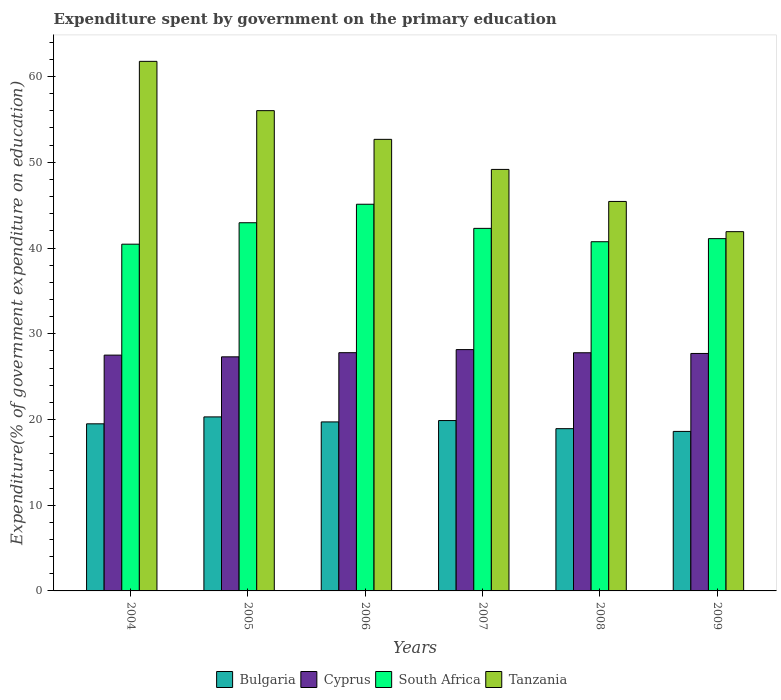How many bars are there on the 5th tick from the right?
Your answer should be very brief. 4. In how many cases, is the number of bars for a given year not equal to the number of legend labels?
Provide a short and direct response. 0. What is the expenditure spent by government on the primary education in Tanzania in 2006?
Make the answer very short. 52.68. Across all years, what is the maximum expenditure spent by government on the primary education in Bulgaria?
Keep it short and to the point. 20.3. Across all years, what is the minimum expenditure spent by government on the primary education in Bulgaria?
Give a very brief answer. 18.61. In which year was the expenditure spent by government on the primary education in Tanzania maximum?
Provide a short and direct response. 2004. In which year was the expenditure spent by government on the primary education in South Africa minimum?
Provide a short and direct response. 2004. What is the total expenditure spent by government on the primary education in Bulgaria in the graph?
Ensure brevity in your answer.  116.92. What is the difference between the expenditure spent by government on the primary education in Bulgaria in 2008 and that in 2009?
Your answer should be very brief. 0.32. What is the difference between the expenditure spent by government on the primary education in Bulgaria in 2007 and the expenditure spent by government on the primary education in Tanzania in 2006?
Provide a succinct answer. -32.8. What is the average expenditure spent by government on the primary education in Bulgaria per year?
Offer a very short reply. 19.49. In the year 2005, what is the difference between the expenditure spent by government on the primary education in Bulgaria and expenditure spent by government on the primary education in Tanzania?
Your response must be concise. -35.72. In how many years, is the expenditure spent by government on the primary education in Bulgaria greater than 2 %?
Provide a succinct answer. 6. What is the ratio of the expenditure spent by government on the primary education in South Africa in 2008 to that in 2009?
Offer a very short reply. 0.99. Is the expenditure spent by government on the primary education in Bulgaria in 2005 less than that in 2007?
Your response must be concise. No. Is the difference between the expenditure spent by government on the primary education in Bulgaria in 2005 and 2008 greater than the difference between the expenditure spent by government on the primary education in Tanzania in 2005 and 2008?
Your response must be concise. No. What is the difference between the highest and the second highest expenditure spent by government on the primary education in Tanzania?
Offer a very short reply. 5.75. What is the difference between the highest and the lowest expenditure spent by government on the primary education in Tanzania?
Offer a terse response. 19.87. Is the sum of the expenditure spent by government on the primary education in Bulgaria in 2006 and 2007 greater than the maximum expenditure spent by government on the primary education in South Africa across all years?
Your answer should be very brief. No. What does the 4th bar from the left in 2006 represents?
Offer a terse response. Tanzania. What does the 2nd bar from the right in 2006 represents?
Make the answer very short. South Africa. How many bars are there?
Offer a terse response. 24. How many years are there in the graph?
Your answer should be compact. 6. How are the legend labels stacked?
Your response must be concise. Horizontal. What is the title of the graph?
Your answer should be very brief. Expenditure spent by government on the primary education. Does "Australia" appear as one of the legend labels in the graph?
Provide a succinct answer. No. What is the label or title of the Y-axis?
Provide a succinct answer. Expenditure(% of government expenditure on education). What is the Expenditure(% of government expenditure on education) in Bulgaria in 2004?
Make the answer very short. 19.49. What is the Expenditure(% of government expenditure on education) of Cyprus in 2004?
Your response must be concise. 27.51. What is the Expenditure(% of government expenditure on education) of South Africa in 2004?
Your response must be concise. 40.45. What is the Expenditure(% of government expenditure on education) in Tanzania in 2004?
Provide a short and direct response. 61.77. What is the Expenditure(% of government expenditure on education) of Bulgaria in 2005?
Give a very brief answer. 20.3. What is the Expenditure(% of government expenditure on education) of Cyprus in 2005?
Your answer should be compact. 27.31. What is the Expenditure(% of government expenditure on education) of South Africa in 2005?
Give a very brief answer. 42.95. What is the Expenditure(% of government expenditure on education) in Tanzania in 2005?
Your answer should be very brief. 56.02. What is the Expenditure(% of government expenditure on education) in Bulgaria in 2006?
Ensure brevity in your answer.  19.72. What is the Expenditure(% of government expenditure on education) in Cyprus in 2006?
Offer a terse response. 27.79. What is the Expenditure(% of government expenditure on education) of South Africa in 2006?
Your answer should be very brief. 45.11. What is the Expenditure(% of government expenditure on education) in Tanzania in 2006?
Offer a terse response. 52.68. What is the Expenditure(% of government expenditure on education) in Bulgaria in 2007?
Make the answer very short. 19.87. What is the Expenditure(% of government expenditure on education) of Cyprus in 2007?
Offer a terse response. 28.15. What is the Expenditure(% of government expenditure on education) of South Africa in 2007?
Give a very brief answer. 42.29. What is the Expenditure(% of government expenditure on education) of Tanzania in 2007?
Offer a very short reply. 49.17. What is the Expenditure(% of government expenditure on education) of Bulgaria in 2008?
Provide a short and direct response. 18.93. What is the Expenditure(% of government expenditure on education) of Cyprus in 2008?
Make the answer very short. 27.78. What is the Expenditure(% of government expenditure on education) in South Africa in 2008?
Ensure brevity in your answer.  40.73. What is the Expenditure(% of government expenditure on education) in Tanzania in 2008?
Provide a succinct answer. 45.43. What is the Expenditure(% of government expenditure on education) of Bulgaria in 2009?
Offer a very short reply. 18.61. What is the Expenditure(% of government expenditure on education) in Cyprus in 2009?
Ensure brevity in your answer.  27.7. What is the Expenditure(% of government expenditure on education) in South Africa in 2009?
Make the answer very short. 41.09. What is the Expenditure(% of government expenditure on education) of Tanzania in 2009?
Provide a succinct answer. 41.91. Across all years, what is the maximum Expenditure(% of government expenditure on education) in Bulgaria?
Provide a short and direct response. 20.3. Across all years, what is the maximum Expenditure(% of government expenditure on education) of Cyprus?
Provide a short and direct response. 28.15. Across all years, what is the maximum Expenditure(% of government expenditure on education) in South Africa?
Keep it short and to the point. 45.11. Across all years, what is the maximum Expenditure(% of government expenditure on education) in Tanzania?
Your answer should be very brief. 61.77. Across all years, what is the minimum Expenditure(% of government expenditure on education) of Bulgaria?
Ensure brevity in your answer.  18.61. Across all years, what is the minimum Expenditure(% of government expenditure on education) of Cyprus?
Offer a terse response. 27.31. Across all years, what is the minimum Expenditure(% of government expenditure on education) of South Africa?
Your answer should be compact. 40.45. Across all years, what is the minimum Expenditure(% of government expenditure on education) in Tanzania?
Your answer should be very brief. 41.91. What is the total Expenditure(% of government expenditure on education) in Bulgaria in the graph?
Your answer should be compact. 116.92. What is the total Expenditure(% of government expenditure on education) in Cyprus in the graph?
Offer a very short reply. 166.23. What is the total Expenditure(% of government expenditure on education) of South Africa in the graph?
Your answer should be compact. 252.62. What is the total Expenditure(% of government expenditure on education) of Tanzania in the graph?
Your answer should be very brief. 306.98. What is the difference between the Expenditure(% of government expenditure on education) of Bulgaria in 2004 and that in 2005?
Your answer should be compact. -0.81. What is the difference between the Expenditure(% of government expenditure on education) of Cyprus in 2004 and that in 2005?
Provide a succinct answer. 0.2. What is the difference between the Expenditure(% of government expenditure on education) of South Africa in 2004 and that in 2005?
Your response must be concise. -2.5. What is the difference between the Expenditure(% of government expenditure on education) of Tanzania in 2004 and that in 2005?
Provide a short and direct response. 5.75. What is the difference between the Expenditure(% of government expenditure on education) in Bulgaria in 2004 and that in 2006?
Keep it short and to the point. -0.22. What is the difference between the Expenditure(% of government expenditure on education) in Cyprus in 2004 and that in 2006?
Provide a succinct answer. -0.28. What is the difference between the Expenditure(% of government expenditure on education) in South Africa in 2004 and that in 2006?
Provide a short and direct response. -4.66. What is the difference between the Expenditure(% of government expenditure on education) in Tanzania in 2004 and that in 2006?
Your response must be concise. 9.1. What is the difference between the Expenditure(% of government expenditure on education) in Bulgaria in 2004 and that in 2007?
Keep it short and to the point. -0.38. What is the difference between the Expenditure(% of government expenditure on education) of Cyprus in 2004 and that in 2007?
Make the answer very short. -0.64. What is the difference between the Expenditure(% of government expenditure on education) of South Africa in 2004 and that in 2007?
Your answer should be very brief. -1.85. What is the difference between the Expenditure(% of government expenditure on education) of Tanzania in 2004 and that in 2007?
Make the answer very short. 12.61. What is the difference between the Expenditure(% of government expenditure on education) in Bulgaria in 2004 and that in 2008?
Your answer should be very brief. 0.56. What is the difference between the Expenditure(% of government expenditure on education) of Cyprus in 2004 and that in 2008?
Give a very brief answer. -0.27. What is the difference between the Expenditure(% of government expenditure on education) of South Africa in 2004 and that in 2008?
Give a very brief answer. -0.29. What is the difference between the Expenditure(% of government expenditure on education) of Tanzania in 2004 and that in 2008?
Ensure brevity in your answer.  16.34. What is the difference between the Expenditure(% of government expenditure on education) in Bulgaria in 2004 and that in 2009?
Your answer should be very brief. 0.89. What is the difference between the Expenditure(% of government expenditure on education) in Cyprus in 2004 and that in 2009?
Ensure brevity in your answer.  -0.19. What is the difference between the Expenditure(% of government expenditure on education) in South Africa in 2004 and that in 2009?
Offer a terse response. -0.65. What is the difference between the Expenditure(% of government expenditure on education) in Tanzania in 2004 and that in 2009?
Provide a short and direct response. 19.87. What is the difference between the Expenditure(% of government expenditure on education) of Bulgaria in 2005 and that in 2006?
Keep it short and to the point. 0.58. What is the difference between the Expenditure(% of government expenditure on education) of Cyprus in 2005 and that in 2006?
Give a very brief answer. -0.48. What is the difference between the Expenditure(% of government expenditure on education) of South Africa in 2005 and that in 2006?
Your answer should be compact. -2.16. What is the difference between the Expenditure(% of government expenditure on education) in Tanzania in 2005 and that in 2006?
Your answer should be compact. 3.35. What is the difference between the Expenditure(% of government expenditure on education) of Bulgaria in 2005 and that in 2007?
Your answer should be very brief. 0.43. What is the difference between the Expenditure(% of government expenditure on education) of Cyprus in 2005 and that in 2007?
Your answer should be very brief. -0.84. What is the difference between the Expenditure(% of government expenditure on education) in South Africa in 2005 and that in 2007?
Keep it short and to the point. 0.66. What is the difference between the Expenditure(% of government expenditure on education) of Tanzania in 2005 and that in 2007?
Offer a terse response. 6.85. What is the difference between the Expenditure(% of government expenditure on education) in Bulgaria in 2005 and that in 2008?
Your answer should be compact. 1.37. What is the difference between the Expenditure(% of government expenditure on education) of Cyprus in 2005 and that in 2008?
Provide a short and direct response. -0.48. What is the difference between the Expenditure(% of government expenditure on education) in South Africa in 2005 and that in 2008?
Ensure brevity in your answer.  2.21. What is the difference between the Expenditure(% of government expenditure on education) of Tanzania in 2005 and that in 2008?
Make the answer very short. 10.59. What is the difference between the Expenditure(% of government expenditure on education) in Bulgaria in 2005 and that in 2009?
Provide a succinct answer. 1.69. What is the difference between the Expenditure(% of government expenditure on education) in Cyprus in 2005 and that in 2009?
Make the answer very short. -0.4. What is the difference between the Expenditure(% of government expenditure on education) of South Africa in 2005 and that in 2009?
Offer a very short reply. 1.85. What is the difference between the Expenditure(% of government expenditure on education) in Tanzania in 2005 and that in 2009?
Your answer should be compact. 14.12. What is the difference between the Expenditure(% of government expenditure on education) in Bulgaria in 2006 and that in 2007?
Your response must be concise. -0.16. What is the difference between the Expenditure(% of government expenditure on education) of Cyprus in 2006 and that in 2007?
Your answer should be compact. -0.36. What is the difference between the Expenditure(% of government expenditure on education) in South Africa in 2006 and that in 2007?
Your response must be concise. 2.81. What is the difference between the Expenditure(% of government expenditure on education) in Tanzania in 2006 and that in 2007?
Offer a terse response. 3.51. What is the difference between the Expenditure(% of government expenditure on education) of Bulgaria in 2006 and that in 2008?
Make the answer very short. 0.79. What is the difference between the Expenditure(% of government expenditure on education) of Cyprus in 2006 and that in 2008?
Keep it short and to the point. 0.01. What is the difference between the Expenditure(% of government expenditure on education) of South Africa in 2006 and that in 2008?
Your response must be concise. 4.37. What is the difference between the Expenditure(% of government expenditure on education) of Tanzania in 2006 and that in 2008?
Your answer should be very brief. 7.24. What is the difference between the Expenditure(% of government expenditure on education) of Bulgaria in 2006 and that in 2009?
Keep it short and to the point. 1.11. What is the difference between the Expenditure(% of government expenditure on education) in Cyprus in 2006 and that in 2009?
Keep it short and to the point. 0.09. What is the difference between the Expenditure(% of government expenditure on education) of South Africa in 2006 and that in 2009?
Your answer should be very brief. 4.01. What is the difference between the Expenditure(% of government expenditure on education) in Tanzania in 2006 and that in 2009?
Ensure brevity in your answer.  10.77. What is the difference between the Expenditure(% of government expenditure on education) in Bulgaria in 2007 and that in 2008?
Provide a succinct answer. 0.95. What is the difference between the Expenditure(% of government expenditure on education) of Cyprus in 2007 and that in 2008?
Provide a short and direct response. 0.37. What is the difference between the Expenditure(% of government expenditure on education) in South Africa in 2007 and that in 2008?
Provide a short and direct response. 1.56. What is the difference between the Expenditure(% of government expenditure on education) of Tanzania in 2007 and that in 2008?
Keep it short and to the point. 3.74. What is the difference between the Expenditure(% of government expenditure on education) of Bulgaria in 2007 and that in 2009?
Your response must be concise. 1.27. What is the difference between the Expenditure(% of government expenditure on education) of Cyprus in 2007 and that in 2009?
Make the answer very short. 0.45. What is the difference between the Expenditure(% of government expenditure on education) in South Africa in 2007 and that in 2009?
Your answer should be compact. 1.2. What is the difference between the Expenditure(% of government expenditure on education) in Tanzania in 2007 and that in 2009?
Give a very brief answer. 7.26. What is the difference between the Expenditure(% of government expenditure on education) of Bulgaria in 2008 and that in 2009?
Give a very brief answer. 0.32. What is the difference between the Expenditure(% of government expenditure on education) in Cyprus in 2008 and that in 2009?
Offer a terse response. 0.08. What is the difference between the Expenditure(% of government expenditure on education) of South Africa in 2008 and that in 2009?
Provide a succinct answer. -0.36. What is the difference between the Expenditure(% of government expenditure on education) of Tanzania in 2008 and that in 2009?
Give a very brief answer. 3.53. What is the difference between the Expenditure(% of government expenditure on education) of Bulgaria in 2004 and the Expenditure(% of government expenditure on education) of Cyprus in 2005?
Give a very brief answer. -7.81. What is the difference between the Expenditure(% of government expenditure on education) in Bulgaria in 2004 and the Expenditure(% of government expenditure on education) in South Africa in 2005?
Provide a succinct answer. -23.46. What is the difference between the Expenditure(% of government expenditure on education) of Bulgaria in 2004 and the Expenditure(% of government expenditure on education) of Tanzania in 2005?
Offer a very short reply. -36.53. What is the difference between the Expenditure(% of government expenditure on education) of Cyprus in 2004 and the Expenditure(% of government expenditure on education) of South Africa in 2005?
Offer a terse response. -15.44. What is the difference between the Expenditure(% of government expenditure on education) of Cyprus in 2004 and the Expenditure(% of government expenditure on education) of Tanzania in 2005?
Your answer should be compact. -28.52. What is the difference between the Expenditure(% of government expenditure on education) of South Africa in 2004 and the Expenditure(% of government expenditure on education) of Tanzania in 2005?
Offer a terse response. -15.58. What is the difference between the Expenditure(% of government expenditure on education) of Bulgaria in 2004 and the Expenditure(% of government expenditure on education) of Cyprus in 2006?
Offer a terse response. -8.3. What is the difference between the Expenditure(% of government expenditure on education) of Bulgaria in 2004 and the Expenditure(% of government expenditure on education) of South Africa in 2006?
Offer a very short reply. -25.61. What is the difference between the Expenditure(% of government expenditure on education) in Bulgaria in 2004 and the Expenditure(% of government expenditure on education) in Tanzania in 2006?
Ensure brevity in your answer.  -33.18. What is the difference between the Expenditure(% of government expenditure on education) of Cyprus in 2004 and the Expenditure(% of government expenditure on education) of South Africa in 2006?
Your answer should be very brief. -17.6. What is the difference between the Expenditure(% of government expenditure on education) in Cyprus in 2004 and the Expenditure(% of government expenditure on education) in Tanzania in 2006?
Keep it short and to the point. -25.17. What is the difference between the Expenditure(% of government expenditure on education) of South Africa in 2004 and the Expenditure(% of government expenditure on education) of Tanzania in 2006?
Offer a very short reply. -12.23. What is the difference between the Expenditure(% of government expenditure on education) in Bulgaria in 2004 and the Expenditure(% of government expenditure on education) in Cyprus in 2007?
Make the answer very short. -8.66. What is the difference between the Expenditure(% of government expenditure on education) of Bulgaria in 2004 and the Expenditure(% of government expenditure on education) of South Africa in 2007?
Give a very brief answer. -22.8. What is the difference between the Expenditure(% of government expenditure on education) in Bulgaria in 2004 and the Expenditure(% of government expenditure on education) in Tanzania in 2007?
Make the answer very short. -29.68. What is the difference between the Expenditure(% of government expenditure on education) in Cyprus in 2004 and the Expenditure(% of government expenditure on education) in South Africa in 2007?
Offer a very short reply. -14.79. What is the difference between the Expenditure(% of government expenditure on education) of Cyprus in 2004 and the Expenditure(% of government expenditure on education) of Tanzania in 2007?
Give a very brief answer. -21.66. What is the difference between the Expenditure(% of government expenditure on education) of South Africa in 2004 and the Expenditure(% of government expenditure on education) of Tanzania in 2007?
Your answer should be very brief. -8.72. What is the difference between the Expenditure(% of government expenditure on education) in Bulgaria in 2004 and the Expenditure(% of government expenditure on education) in Cyprus in 2008?
Give a very brief answer. -8.29. What is the difference between the Expenditure(% of government expenditure on education) of Bulgaria in 2004 and the Expenditure(% of government expenditure on education) of South Africa in 2008?
Give a very brief answer. -21.24. What is the difference between the Expenditure(% of government expenditure on education) of Bulgaria in 2004 and the Expenditure(% of government expenditure on education) of Tanzania in 2008?
Keep it short and to the point. -25.94. What is the difference between the Expenditure(% of government expenditure on education) of Cyprus in 2004 and the Expenditure(% of government expenditure on education) of South Africa in 2008?
Your answer should be very brief. -13.23. What is the difference between the Expenditure(% of government expenditure on education) in Cyprus in 2004 and the Expenditure(% of government expenditure on education) in Tanzania in 2008?
Your answer should be compact. -17.93. What is the difference between the Expenditure(% of government expenditure on education) of South Africa in 2004 and the Expenditure(% of government expenditure on education) of Tanzania in 2008?
Provide a short and direct response. -4.99. What is the difference between the Expenditure(% of government expenditure on education) in Bulgaria in 2004 and the Expenditure(% of government expenditure on education) in Cyprus in 2009?
Your answer should be compact. -8.21. What is the difference between the Expenditure(% of government expenditure on education) in Bulgaria in 2004 and the Expenditure(% of government expenditure on education) in South Africa in 2009?
Give a very brief answer. -21.6. What is the difference between the Expenditure(% of government expenditure on education) in Bulgaria in 2004 and the Expenditure(% of government expenditure on education) in Tanzania in 2009?
Your answer should be very brief. -22.41. What is the difference between the Expenditure(% of government expenditure on education) of Cyprus in 2004 and the Expenditure(% of government expenditure on education) of South Africa in 2009?
Provide a short and direct response. -13.59. What is the difference between the Expenditure(% of government expenditure on education) of Cyprus in 2004 and the Expenditure(% of government expenditure on education) of Tanzania in 2009?
Give a very brief answer. -14.4. What is the difference between the Expenditure(% of government expenditure on education) in South Africa in 2004 and the Expenditure(% of government expenditure on education) in Tanzania in 2009?
Your answer should be compact. -1.46. What is the difference between the Expenditure(% of government expenditure on education) in Bulgaria in 2005 and the Expenditure(% of government expenditure on education) in Cyprus in 2006?
Provide a succinct answer. -7.49. What is the difference between the Expenditure(% of government expenditure on education) of Bulgaria in 2005 and the Expenditure(% of government expenditure on education) of South Africa in 2006?
Your answer should be very brief. -24.81. What is the difference between the Expenditure(% of government expenditure on education) in Bulgaria in 2005 and the Expenditure(% of government expenditure on education) in Tanzania in 2006?
Keep it short and to the point. -32.38. What is the difference between the Expenditure(% of government expenditure on education) of Cyprus in 2005 and the Expenditure(% of government expenditure on education) of South Africa in 2006?
Provide a succinct answer. -17.8. What is the difference between the Expenditure(% of government expenditure on education) of Cyprus in 2005 and the Expenditure(% of government expenditure on education) of Tanzania in 2006?
Your answer should be very brief. -25.37. What is the difference between the Expenditure(% of government expenditure on education) in South Africa in 2005 and the Expenditure(% of government expenditure on education) in Tanzania in 2006?
Your answer should be compact. -9.73. What is the difference between the Expenditure(% of government expenditure on education) in Bulgaria in 2005 and the Expenditure(% of government expenditure on education) in Cyprus in 2007?
Provide a short and direct response. -7.85. What is the difference between the Expenditure(% of government expenditure on education) of Bulgaria in 2005 and the Expenditure(% of government expenditure on education) of South Africa in 2007?
Offer a very short reply. -21.99. What is the difference between the Expenditure(% of government expenditure on education) of Bulgaria in 2005 and the Expenditure(% of government expenditure on education) of Tanzania in 2007?
Your answer should be very brief. -28.87. What is the difference between the Expenditure(% of government expenditure on education) of Cyprus in 2005 and the Expenditure(% of government expenditure on education) of South Africa in 2007?
Your answer should be compact. -14.99. What is the difference between the Expenditure(% of government expenditure on education) of Cyprus in 2005 and the Expenditure(% of government expenditure on education) of Tanzania in 2007?
Your response must be concise. -21.86. What is the difference between the Expenditure(% of government expenditure on education) in South Africa in 2005 and the Expenditure(% of government expenditure on education) in Tanzania in 2007?
Your answer should be very brief. -6.22. What is the difference between the Expenditure(% of government expenditure on education) in Bulgaria in 2005 and the Expenditure(% of government expenditure on education) in Cyprus in 2008?
Make the answer very short. -7.48. What is the difference between the Expenditure(% of government expenditure on education) of Bulgaria in 2005 and the Expenditure(% of government expenditure on education) of South Africa in 2008?
Provide a short and direct response. -20.43. What is the difference between the Expenditure(% of government expenditure on education) in Bulgaria in 2005 and the Expenditure(% of government expenditure on education) in Tanzania in 2008?
Offer a terse response. -25.13. What is the difference between the Expenditure(% of government expenditure on education) in Cyprus in 2005 and the Expenditure(% of government expenditure on education) in South Africa in 2008?
Provide a short and direct response. -13.43. What is the difference between the Expenditure(% of government expenditure on education) of Cyprus in 2005 and the Expenditure(% of government expenditure on education) of Tanzania in 2008?
Keep it short and to the point. -18.13. What is the difference between the Expenditure(% of government expenditure on education) of South Africa in 2005 and the Expenditure(% of government expenditure on education) of Tanzania in 2008?
Offer a very short reply. -2.48. What is the difference between the Expenditure(% of government expenditure on education) of Bulgaria in 2005 and the Expenditure(% of government expenditure on education) of Cyprus in 2009?
Your response must be concise. -7.4. What is the difference between the Expenditure(% of government expenditure on education) of Bulgaria in 2005 and the Expenditure(% of government expenditure on education) of South Africa in 2009?
Offer a very short reply. -20.79. What is the difference between the Expenditure(% of government expenditure on education) in Bulgaria in 2005 and the Expenditure(% of government expenditure on education) in Tanzania in 2009?
Your response must be concise. -21.61. What is the difference between the Expenditure(% of government expenditure on education) in Cyprus in 2005 and the Expenditure(% of government expenditure on education) in South Africa in 2009?
Ensure brevity in your answer.  -13.79. What is the difference between the Expenditure(% of government expenditure on education) of Cyprus in 2005 and the Expenditure(% of government expenditure on education) of Tanzania in 2009?
Offer a terse response. -14.6. What is the difference between the Expenditure(% of government expenditure on education) in South Africa in 2005 and the Expenditure(% of government expenditure on education) in Tanzania in 2009?
Make the answer very short. 1.04. What is the difference between the Expenditure(% of government expenditure on education) of Bulgaria in 2006 and the Expenditure(% of government expenditure on education) of Cyprus in 2007?
Offer a very short reply. -8.43. What is the difference between the Expenditure(% of government expenditure on education) in Bulgaria in 2006 and the Expenditure(% of government expenditure on education) in South Africa in 2007?
Provide a succinct answer. -22.58. What is the difference between the Expenditure(% of government expenditure on education) in Bulgaria in 2006 and the Expenditure(% of government expenditure on education) in Tanzania in 2007?
Your response must be concise. -29.45. What is the difference between the Expenditure(% of government expenditure on education) of Cyprus in 2006 and the Expenditure(% of government expenditure on education) of South Africa in 2007?
Your answer should be very brief. -14.5. What is the difference between the Expenditure(% of government expenditure on education) in Cyprus in 2006 and the Expenditure(% of government expenditure on education) in Tanzania in 2007?
Ensure brevity in your answer.  -21.38. What is the difference between the Expenditure(% of government expenditure on education) of South Africa in 2006 and the Expenditure(% of government expenditure on education) of Tanzania in 2007?
Provide a succinct answer. -4.06. What is the difference between the Expenditure(% of government expenditure on education) of Bulgaria in 2006 and the Expenditure(% of government expenditure on education) of Cyprus in 2008?
Keep it short and to the point. -8.07. What is the difference between the Expenditure(% of government expenditure on education) in Bulgaria in 2006 and the Expenditure(% of government expenditure on education) in South Africa in 2008?
Your answer should be very brief. -21.02. What is the difference between the Expenditure(% of government expenditure on education) in Bulgaria in 2006 and the Expenditure(% of government expenditure on education) in Tanzania in 2008?
Make the answer very short. -25.72. What is the difference between the Expenditure(% of government expenditure on education) of Cyprus in 2006 and the Expenditure(% of government expenditure on education) of South Africa in 2008?
Keep it short and to the point. -12.94. What is the difference between the Expenditure(% of government expenditure on education) of Cyprus in 2006 and the Expenditure(% of government expenditure on education) of Tanzania in 2008?
Ensure brevity in your answer.  -17.64. What is the difference between the Expenditure(% of government expenditure on education) of South Africa in 2006 and the Expenditure(% of government expenditure on education) of Tanzania in 2008?
Offer a terse response. -0.33. What is the difference between the Expenditure(% of government expenditure on education) in Bulgaria in 2006 and the Expenditure(% of government expenditure on education) in Cyprus in 2009?
Keep it short and to the point. -7.98. What is the difference between the Expenditure(% of government expenditure on education) in Bulgaria in 2006 and the Expenditure(% of government expenditure on education) in South Africa in 2009?
Offer a terse response. -21.38. What is the difference between the Expenditure(% of government expenditure on education) of Bulgaria in 2006 and the Expenditure(% of government expenditure on education) of Tanzania in 2009?
Offer a very short reply. -22.19. What is the difference between the Expenditure(% of government expenditure on education) of Cyprus in 2006 and the Expenditure(% of government expenditure on education) of South Africa in 2009?
Offer a very short reply. -13.3. What is the difference between the Expenditure(% of government expenditure on education) of Cyprus in 2006 and the Expenditure(% of government expenditure on education) of Tanzania in 2009?
Your response must be concise. -14.12. What is the difference between the Expenditure(% of government expenditure on education) of Bulgaria in 2007 and the Expenditure(% of government expenditure on education) of Cyprus in 2008?
Offer a terse response. -7.91. What is the difference between the Expenditure(% of government expenditure on education) of Bulgaria in 2007 and the Expenditure(% of government expenditure on education) of South Africa in 2008?
Provide a succinct answer. -20.86. What is the difference between the Expenditure(% of government expenditure on education) in Bulgaria in 2007 and the Expenditure(% of government expenditure on education) in Tanzania in 2008?
Ensure brevity in your answer.  -25.56. What is the difference between the Expenditure(% of government expenditure on education) of Cyprus in 2007 and the Expenditure(% of government expenditure on education) of South Africa in 2008?
Ensure brevity in your answer.  -12.58. What is the difference between the Expenditure(% of government expenditure on education) in Cyprus in 2007 and the Expenditure(% of government expenditure on education) in Tanzania in 2008?
Provide a succinct answer. -17.28. What is the difference between the Expenditure(% of government expenditure on education) of South Africa in 2007 and the Expenditure(% of government expenditure on education) of Tanzania in 2008?
Give a very brief answer. -3.14. What is the difference between the Expenditure(% of government expenditure on education) of Bulgaria in 2007 and the Expenditure(% of government expenditure on education) of Cyprus in 2009?
Your answer should be compact. -7.83. What is the difference between the Expenditure(% of government expenditure on education) in Bulgaria in 2007 and the Expenditure(% of government expenditure on education) in South Africa in 2009?
Give a very brief answer. -21.22. What is the difference between the Expenditure(% of government expenditure on education) in Bulgaria in 2007 and the Expenditure(% of government expenditure on education) in Tanzania in 2009?
Your response must be concise. -22.03. What is the difference between the Expenditure(% of government expenditure on education) of Cyprus in 2007 and the Expenditure(% of government expenditure on education) of South Africa in 2009?
Make the answer very short. -12.95. What is the difference between the Expenditure(% of government expenditure on education) of Cyprus in 2007 and the Expenditure(% of government expenditure on education) of Tanzania in 2009?
Make the answer very short. -13.76. What is the difference between the Expenditure(% of government expenditure on education) in South Africa in 2007 and the Expenditure(% of government expenditure on education) in Tanzania in 2009?
Your response must be concise. 0.39. What is the difference between the Expenditure(% of government expenditure on education) of Bulgaria in 2008 and the Expenditure(% of government expenditure on education) of Cyprus in 2009?
Ensure brevity in your answer.  -8.77. What is the difference between the Expenditure(% of government expenditure on education) of Bulgaria in 2008 and the Expenditure(% of government expenditure on education) of South Africa in 2009?
Keep it short and to the point. -22.17. What is the difference between the Expenditure(% of government expenditure on education) of Bulgaria in 2008 and the Expenditure(% of government expenditure on education) of Tanzania in 2009?
Make the answer very short. -22.98. What is the difference between the Expenditure(% of government expenditure on education) in Cyprus in 2008 and the Expenditure(% of government expenditure on education) in South Africa in 2009?
Offer a terse response. -13.31. What is the difference between the Expenditure(% of government expenditure on education) of Cyprus in 2008 and the Expenditure(% of government expenditure on education) of Tanzania in 2009?
Provide a short and direct response. -14.13. What is the difference between the Expenditure(% of government expenditure on education) in South Africa in 2008 and the Expenditure(% of government expenditure on education) in Tanzania in 2009?
Keep it short and to the point. -1.17. What is the average Expenditure(% of government expenditure on education) in Bulgaria per year?
Your answer should be compact. 19.49. What is the average Expenditure(% of government expenditure on education) of Cyprus per year?
Your answer should be compact. 27.71. What is the average Expenditure(% of government expenditure on education) in South Africa per year?
Make the answer very short. 42.1. What is the average Expenditure(% of government expenditure on education) in Tanzania per year?
Your answer should be very brief. 51.16. In the year 2004, what is the difference between the Expenditure(% of government expenditure on education) in Bulgaria and Expenditure(% of government expenditure on education) in Cyprus?
Ensure brevity in your answer.  -8.01. In the year 2004, what is the difference between the Expenditure(% of government expenditure on education) of Bulgaria and Expenditure(% of government expenditure on education) of South Africa?
Your response must be concise. -20.95. In the year 2004, what is the difference between the Expenditure(% of government expenditure on education) of Bulgaria and Expenditure(% of government expenditure on education) of Tanzania?
Give a very brief answer. -42.28. In the year 2004, what is the difference between the Expenditure(% of government expenditure on education) of Cyprus and Expenditure(% of government expenditure on education) of South Africa?
Your answer should be very brief. -12.94. In the year 2004, what is the difference between the Expenditure(% of government expenditure on education) of Cyprus and Expenditure(% of government expenditure on education) of Tanzania?
Ensure brevity in your answer.  -34.27. In the year 2004, what is the difference between the Expenditure(% of government expenditure on education) in South Africa and Expenditure(% of government expenditure on education) in Tanzania?
Offer a terse response. -21.33. In the year 2005, what is the difference between the Expenditure(% of government expenditure on education) of Bulgaria and Expenditure(% of government expenditure on education) of Cyprus?
Offer a very short reply. -7. In the year 2005, what is the difference between the Expenditure(% of government expenditure on education) of Bulgaria and Expenditure(% of government expenditure on education) of South Africa?
Offer a terse response. -22.65. In the year 2005, what is the difference between the Expenditure(% of government expenditure on education) in Bulgaria and Expenditure(% of government expenditure on education) in Tanzania?
Keep it short and to the point. -35.72. In the year 2005, what is the difference between the Expenditure(% of government expenditure on education) of Cyprus and Expenditure(% of government expenditure on education) of South Africa?
Your response must be concise. -15.64. In the year 2005, what is the difference between the Expenditure(% of government expenditure on education) in Cyprus and Expenditure(% of government expenditure on education) in Tanzania?
Make the answer very short. -28.72. In the year 2005, what is the difference between the Expenditure(% of government expenditure on education) in South Africa and Expenditure(% of government expenditure on education) in Tanzania?
Provide a succinct answer. -13.08. In the year 2006, what is the difference between the Expenditure(% of government expenditure on education) of Bulgaria and Expenditure(% of government expenditure on education) of Cyprus?
Offer a terse response. -8.07. In the year 2006, what is the difference between the Expenditure(% of government expenditure on education) of Bulgaria and Expenditure(% of government expenditure on education) of South Africa?
Your response must be concise. -25.39. In the year 2006, what is the difference between the Expenditure(% of government expenditure on education) in Bulgaria and Expenditure(% of government expenditure on education) in Tanzania?
Offer a very short reply. -32.96. In the year 2006, what is the difference between the Expenditure(% of government expenditure on education) of Cyprus and Expenditure(% of government expenditure on education) of South Africa?
Your answer should be compact. -17.32. In the year 2006, what is the difference between the Expenditure(% of government expenditure on education) in Cyprus and Expenditure(% of government expenditure on education) in Tanzania?
Offer a terse response. -24.89. In the year 2006, what is the difference between the Expenditure(% of government expenditure on education) of South Africa and Expenditure(% of government expenditure on education) of Tanzania?
Your response must be concise. -7.57. In the year 2007, what is the difference between the Expenditure(% of government expenditure on education) in Bulgaria and Expenditure(% of government expenditure on education) in Cyprus?
Make the answer very short. -8.28. In the year 2007, what is the difference between the Expenditure(% of government expenditure on education) of Bulgaria and Expenditure(% of government expenditure on education) of South Africa?
Your response must be concise. -22.42. In the year 2007, what is the difference between the Expenditure(% of government expenditure on education) in Bulgaria and Expenditure(% of government expenditure on education) in Tanzania?
Ensure brevity in your answer.  -29.3. In the year 2007, what is the difference between the Expenditure(% of government expenditure on education) of Cyprus and Expenditure(% of government expenditure on education) of South Africa?
Give a very brief answer. -14.14. In the year 2007, what is the difference between the Expenditure(% of government expenditure on education) in Cyprus and Expenditure(% of government expenditure on education) in Tanzania?
Ensure brevity in your answer.  -21.02. In the year 2007, what is the difference between the Expenditure(% of government expenditure on education) of South Africa and Expenditure(% of government expenditure on education) of Tanzania?
Your answer should be very brief. -6.88. In the year 2008, what is the difference between the Expenditure(% of government expenditure on education) of Bulgaria and Expenditure(% of government expenditure on education) of Cyprus?
Provide a short and direct response. -8.85. In the year 2008, what is the difference between the Expenditure(% of government expenditure on education) of Bulgaria and Expenditure(% of government expenditure on education) of South Africa?
Offer a very short reply. -21.81. In the year 2008, what is the difference between the Expenditure(% of government expenditure on education) of Bulgaria and Expenditure(% of government expenditure on education) of Tanzania?
Make the answer very short. -26.5. In the year 2008, what is the difference between the Expenditure(% of government expenditure on education) of Cyprus and Expenditure(% of government expenditure on education) of South Africa?
Your answer should be very brief. -12.95. In the year 2008, what is the difference between the Expenditure(% of government expenditure on education) in Cyprus and Expenditure(% of government expenditure on education) in Tanzania?
Make the answer very short. -17.65. In the year 2008, what is the difference between the Expenditure(% of government expenditure on education) of South Africa and Expenditure(% of government expenditure on education) of Tanzania?
Provide a succinct answer. -4.7. In the year 2009, what is the difference between the Expenditure(% of government expenditure on education) in Bulgaria and Expenditure(% of government expenditure on education) in Cyprus?
Offer a terse response. -9.09. In the year 2009, what is the difference between the Expenditure(% of government expenditure on education) in Bulgaria and Expenditure(% of government expenditure on education) in South Africa?
Offer a terse response. -22.49. In the year 2009, what is the difference between the Expenditure(% of government expenditure on education) of Bulgaria and Expenditure(% of government expenditure on education) of Tanzania?
Your response must be concise. -23.3. In the year 2009, what is the difference between the Expenditure(% of government expenditure on education) of Cyprus and Expenditure(% of government expenditure on education) of South Africa?
Your answer should be very brief. -13.39. In the year 2009, what is the difference between the Expenditure(% of government expenditure on education) in Cyprus and Expenditure(% of government expenditure on education) in Tanzania?
Your response must be concise. -14.21. In the year 2009, what is the difference between the Expenditure(% of government expenditure on education) of South Africa and Expenditure(% of government expenditure on education) of Tanzania?
Offer a terse response. -0.81. What is the ratio of the Expenditure(% of government expenditure on education) in Bulgaria in 2004 to that in 2005?
Your answer should be very brief. 0.96. What is the ratio of the Expenditure(% of government expenditure on education) in Cyprus in 2004 to that in 2005?
Your response must be concise. 1.01. What is the ratio of the Expenditure(% of government expenditure on education) in South Africa in 2004 to that in 2005?
Make the answer very short. 0.94. What is the ratio of the Expenditure(% of government expenditure on education) in Tanzania in 2004 to that in 2005?
Ensure brevity in your answer.  1.1. What is the ratio of the Expenditure(% of government expenditure on education) in Bulgaria in 2004 to that in 2006?
Give a very brief answer. 0.99. What is the ratio of the Expenditure(% of government expenditure on education) in Cyprus in 2004 to that in 2006?
Give a very brief answer. 0.99. What is the ratio of the Expenditure(% of government expenditure on education) of South Africa in 2004 to that in 2006?
Your answer should be very brief. 0.9. What is the ratio of the Expenditure(% of government expenditure on education) of Tanzania in 2004 to that in 2006?
Your response must be concise. 1.17. What is the ratio of the Expenditure(% of government expenditure on education) of Bulgaria in 2004 to that in 2007?
Offer a terse response. 0.98. What is the ratio of the Expenditure(% of government expenditure on education) of Cyprus in 2004 to that in 2007?
Keep it short and to the point. 0.98. What is the ratio of the Expenditure(% of government expenditure on education) of South Africa in 2004 to that in 2007?
Your answer should be very brief. 0.96. What is the ratio of the Expenditure(% of government expenditure on education) in Tanzania in 2004 to that in 2007?
Give a very brief answer. 1.26. What is the ratio of the Expenditure(% of government expenditure on education) of Bulgaria in 2004 to that in 2008?
Offer a terse response. 1.03. What is the ratio of the Expenditure(% of government expenditure on education) of Cyprus in 2004 to that in 2008?
Ensure brevity in your answer.  0.99. What is the ratio of the Expenditure(% of government expenditure on education) of Tanzania in 2004 to that in 2008?
Make the answer very short. 1.36. What is the ratio of the Expenditure(% of government expenditure on education) of Bulgaria in 2004 to that in 2009?
Your answer should be compact. 1.05. What is the ratio of the Expenditure(% of government expenditure on education) of South Africa in 2004 to that in 2009?
Provide a short and direct response. 0.98. What is the ratio of the Expenditure(% of government expenditure on education) in Tanzania in 2004 to that in 2009?
Provide a succinct answer. 1.47. What is the ratio of the Expenditure(% of government expenditure on education) of Bulgaria in 2005 to that in 2006?
Provide a short and direct response. 1.03. What is the ratio of the Expenditure(% of government expenditure on education) of Cyprus in 2005 to that in 2006?
Provide a short and direct response. 0.98. What is the ratio of the Expenditure(% of government expenditure on education) in South Africa in 2005 to that in 2006?
Make the answer very short. 0.95. What is the ratio of the Expenditure(% of government expenditure on education) of Tanzania in 2005 to that in 2006?
Your answer should be compact. 1.06. What is the ratio of the Expenditure(% of government expenditure on education) in Bulgaria in 2005 to that in 2007?
Make the answer very short. 1.02. What is the ratio of the Expenditure(% of government expenditure on education) in South Africa in 2005 to that in 2007?
Your response must be concise. 1.02. What is the ratio of the Expenditure(% of government expenditure on education) of Tanzania in 2005 to that in 2007?
Provide a succinct answer. 1.14. What is the ratio of the Expenditure(% of government expenditure on education) of Bulgaria in 2005 to that in 2008?
Keep it short and to the point. 1.07. What is the ratio of the Expenditure(% of government expenditure on education) in Cyprus in 2005 to that in 2008?
Your response must be concise. 0.98. What is the ratio of the Expenditure(% of government expenditure on education) of South Africa in 2005 to that in 2008?
Your response must be concise. 1.05. What is the ratio of the Expenditure(% of government expenditure on education) in Tanzania in 2005 to that in 2008?
Ensure brevity in your answer.  1.23. What is the ratio of the Expenditure(% of government expenditure on education) of Bulgaria in 2005 to that in 2009?
Your answer should be very brief. 1.09. What is the ratio of the Expenditure(% of government expenditure on education) of Cyprus in 2005 to that in 2009?
Your answer should be compact. 0.99. What is the ratio of the Expenditure(% of government expenditure on education) of South Africa in 2005 to that in 2009?
Provide a succinct answer. 1.05. What is the ratio of the Expenditure(% of government expenditure on education) of Tanzania in 2005 to that in 2009?
Your answer should be very brief. 1.34. What is the ratio of the Expenditure(% of government expenditure on education) of Bulgaria in 2006 to that in 2007?
Offer a very short reply. 0.99. What is the ratio of the Expenditure(% of government expenditure on education) in Cyprus in 2006 to that in 2007?
Give a very brief answer. 0.99. What is the ratio of the Expenditure(% of government expenditure on education) in South Africa in 2006 to that in 2007?
Offer a very short reply. 1.07. What is the ratio of the Expenditure(% of government expenditure on education) in Tanzania in 2006 to that in 2007?
Offer a terse response. 1.07. What is the ratio of the Expenditure(% of government expenditure on education) in Bulgaria in 2006 to that in 2008?
Make the answer very short. 1.04. What is the ratio of the Expenditure(% of government expenditure on education) of Cyprus in 2006 to that in 2008?
Your answer should be very brief. 1. What is the ratio of the Expenditure(% of government expenditure on education) in South Africa in 2006 to that in 2008?
Offer a terse response. 1.11. What is the ratio of the Expenditure(% of government expenditure on education) in Tanzania in 2006 to that in 2008?
Your response must be concise. 1.16. What is the ratio of the Expenditure(% of government expenditure on education) in Bulgaria in 2006 to that in 2009?
Ensure brevity in your answer.  1.06. What is the ratio of the Expenditure(% of government expenditure on education) in Cyprus in 2006 to that in 2009?
Make the answer very short. 1. What is the ratio of the Expenditure(% of government expenditure on education) in South Africa in 2006 to that in 2009?
Ensure brevity in your answer.  1.1. What is the ratio of the Expenditure(% of government expenditure on education) of Tanzania in 2006 to that in 2009?
Your answer should be compact. 1.26. What is the ratio of the Expenditure(% of government expenditure on education) of Bulgaria in 2007 to that in 2008?
Provide a short and direct response. 1.05. What is the ratio of the Expenditure(% of government expenditure on education) of Cyprus in 2007 to that in 2008?
Keep it short and to the point. 1.01. What is the ratio of the Expenditure(% of government expenditure on education) of South Africa in 2007 to that in 2008?
Offer a terse response. 1.04. What is the ratio of the Expenditure(% of government expenditure on education) in Tanzania in 2007 to that in 2008?
Offer a terse response. 1.08. What is the ratio of the Expenditure(% of government expenditure on education) of Bulgaria in 2007 to that in 2009?
Ensure brevity in your answer.  1.07. What is the ratio of the Expenditure(% of government expenditure on education) in Cyprus in 2007 to that in 2009?
Your answer should be very brief. 1.02. What is the ratio of the Expenditure(% of government expenditure on education) of South Africa in 2007 to that in 2009?
Give a very brief answer. 1.03. What is the ratio of the Expenditure(% of government expenditure on education) in Tanzania in 2007 to that in 2009?
Offer a terse response. 1.17. What is the ratio of the Expenditure(% of government expenditure on education) in Bulgaria in 2008 to that in 2009?
Provide a short and direct response. 1.02. What is the ratio of the Expenditure(% of government expenditure on education) in South Africa in 2008 to that in 2009?
Your response must be concise. 0.99. What is the ratio of the Expenditure(% of government expenditure on education) of Tanzania in 2008 to that in 2009?
Offer a terse response. 1.08. What is the difference between the highest and the second highest Expenditure(% of government expenditure on education) in Bulgaria?
Provide a short and direct response. 0.43. What is the difference between the highest and the second highest Expenditure(% of government expenditure on education) in Cyprus?
Provide a succinct answer. 0.36. What is the difference between the highest and the second highest Expenditure(% of government expenditure on education) in South Africa?
Your answer should be compact. 2.16. What is the difference between the highest and the second highest Expenditure(% of government expenditure on education) of Tanzania?
Your response must be concise. 5.75. What is the difference between the highest and the lowest Expenditure(% of government expenditure on education) in Bulgaria?
Offer a terse response. 1.69. What is the difference between the highest and the lowest Expenditure(% of government expenditure on education) in Cyprus?
Provide a succinct answer. 0.84. What is the difference between the highest and the lowest Expenditure(% of government expenditure on education) of South Africa?
Your answer should be very brief. 4.66. What is the difference between the highest and the lowest Expenditure(% of government expenditure on education) of Tanzania?
Provide a succinct answer. 19.87. 